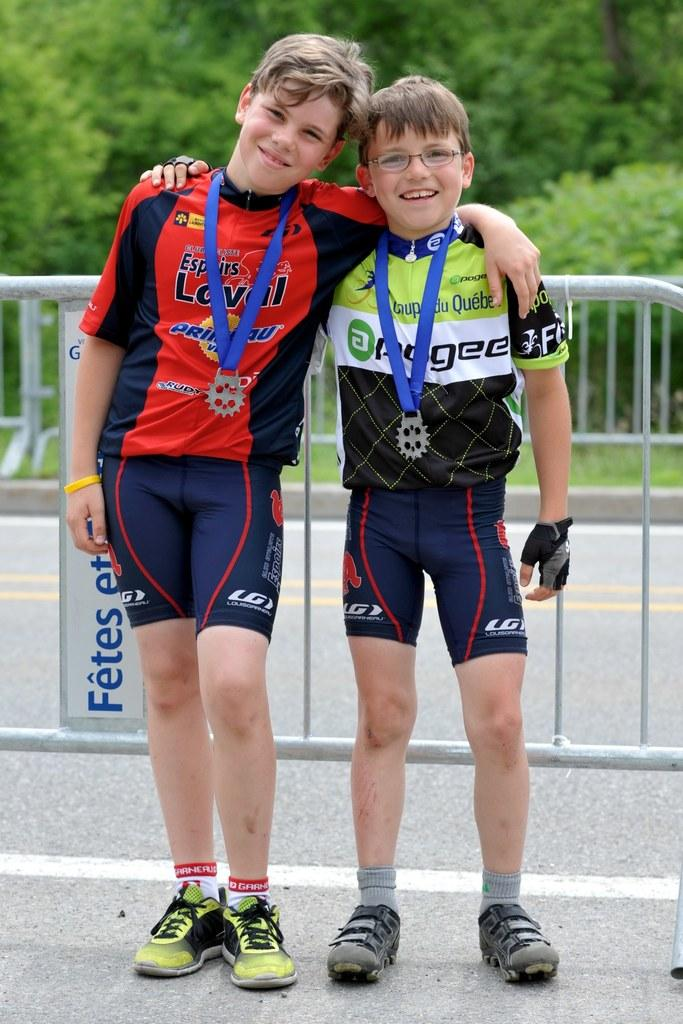<image>
Render a clear and concise summary of the photo. Two boys standing next to each other with the boy on the left wearing a red shirt with the word Rudy on it. 